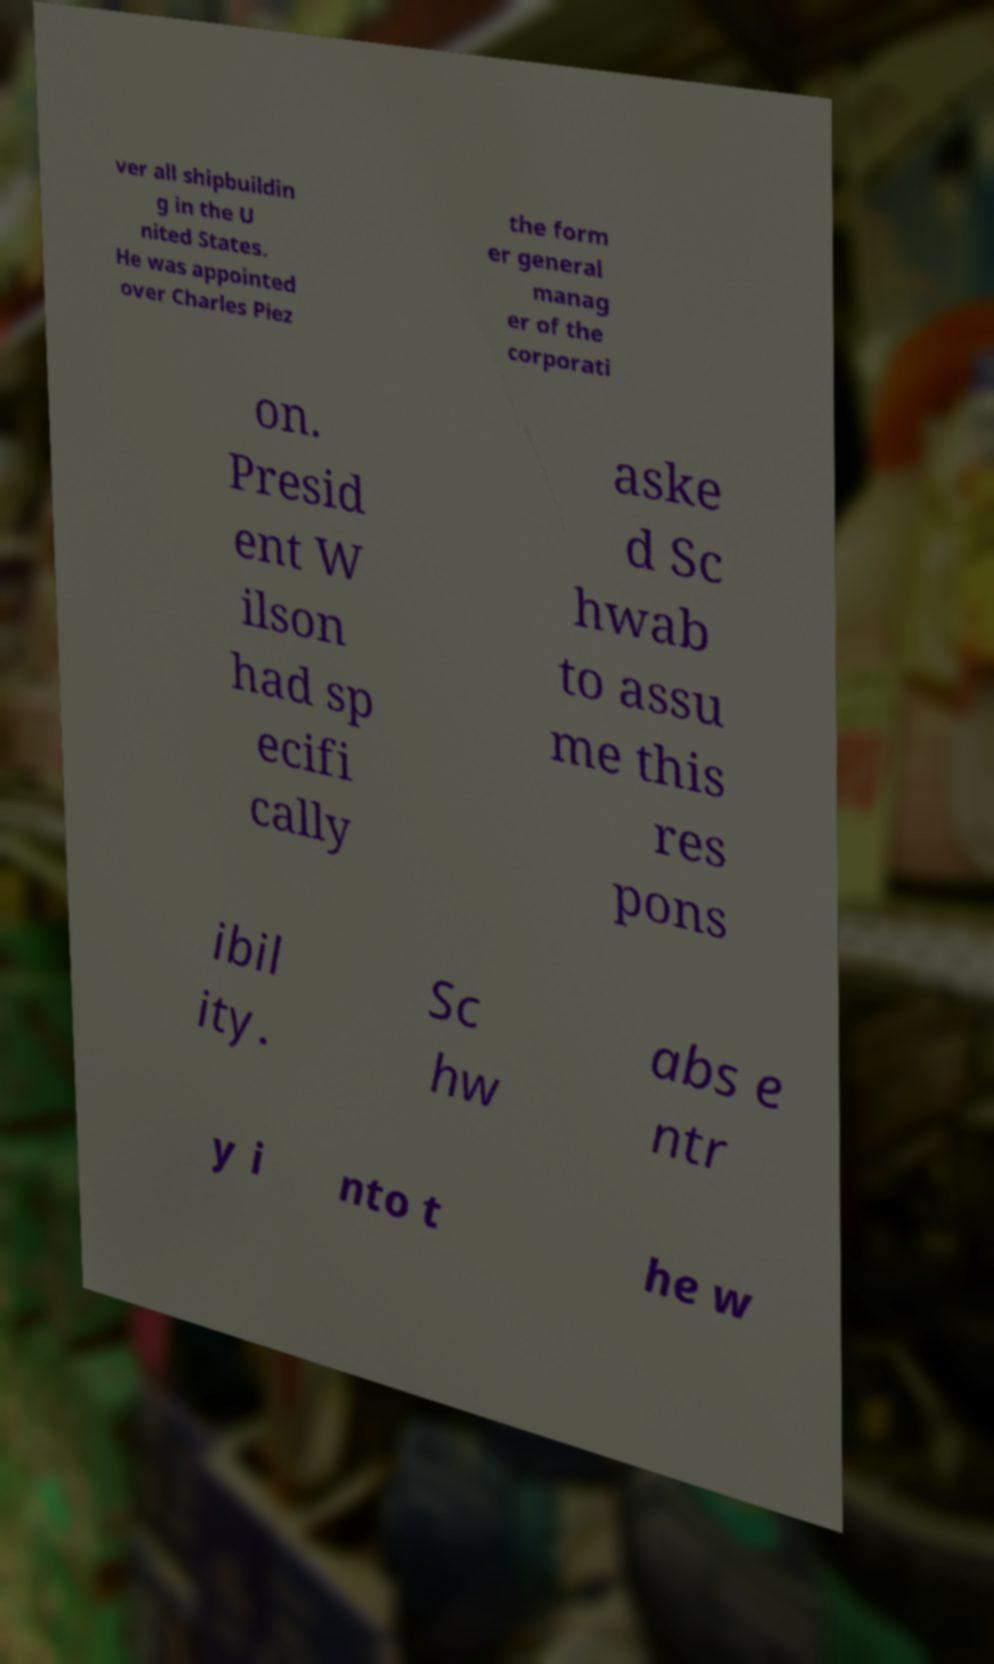For documentation purposes, I need the text within this image transcribed. Could you provide that? ver all shipbuildin g in the U nited States. He was appointed over Charles Piez the form er general manag er of the corporati on. Presid ent W ilson had sp ecifi cally aske d Sc hwab to assu me this res pons ibil ity. Sc hw abs e ntr y i nto t he w 